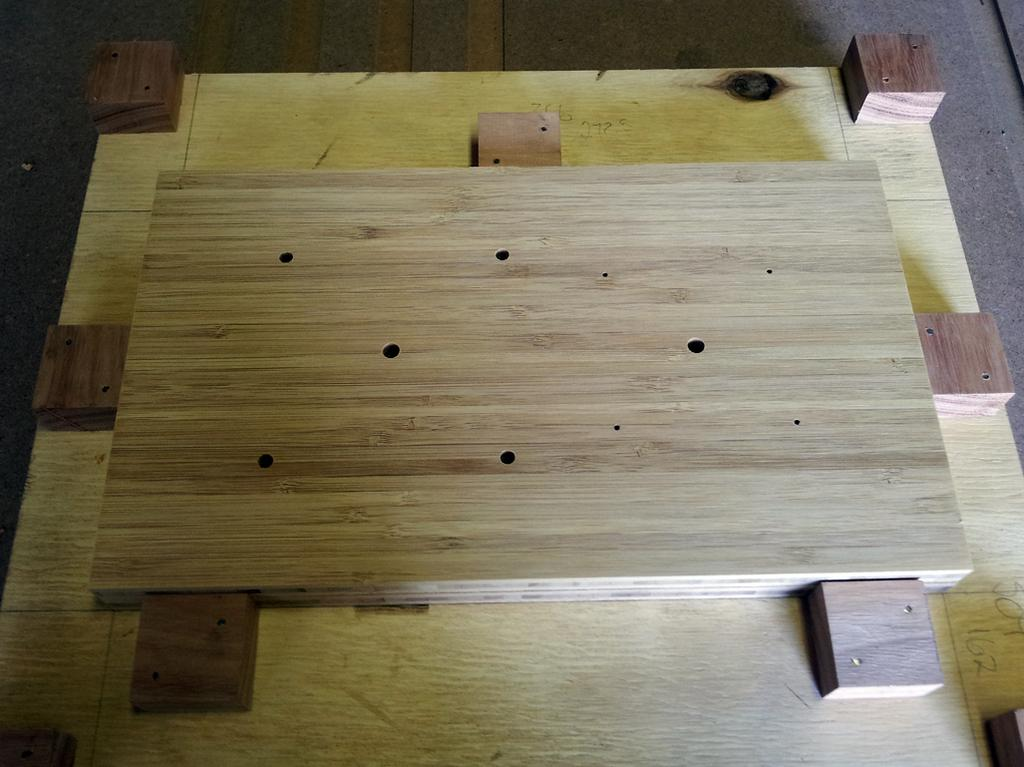What material is the main object in the image made of? The main object in the image is made of wood. Can you describe the object in more detail? The object is a wooden board. What type of shoes are being worn by the wooden board in the image? There are no shoes or people present in the image, as it only features a wooden board. 